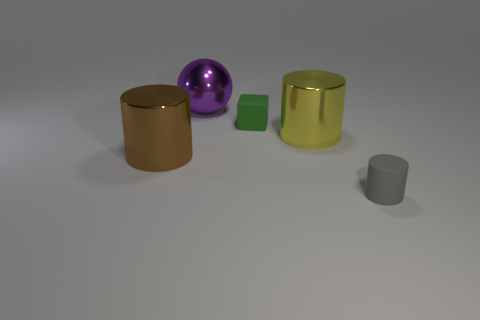Subtract 1 cylinders. How many cylinders are left? 2 Add 1 big yellow shiny cylinders. How many objects exist? 6 Subtract all spheres. How many objects are left? 4 Subtract all green rubber cubes. Subtract all big purple spheres. How many objects are left? 3 Add 5 matte blocks. How many matte blocks are left? 6 Add 3 rubber cylinders. How many rubber cylinders exist? 4 Subtract 0 cyan balls. How many objects are left? 5 